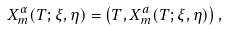<formula> <loc_0><loc_0><loc_500><loc_500>X _ { m } ^ { \alpha } ( T ; \xi , \eta ) = \left ( T , X _ { m } ^ { a } ( T ; \xi , \eta ) \right ) ,</formula> 